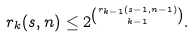<formula> <loc_0><loc_0><loc_500><loc_500>r _ { k } ( s , n ) \leq 2 ^ { { r _ { k - 1 } ( s - 1 , n - 1 ) \choose k - 1 } } .</formula> 